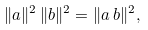<formula> <loc_0><loc_0><loc_500><loc_500>\| a \| ^ { 2 } \, \| b \| ^ { 2 } = \| a \, b \| ^ { 2 } ,</formula> 